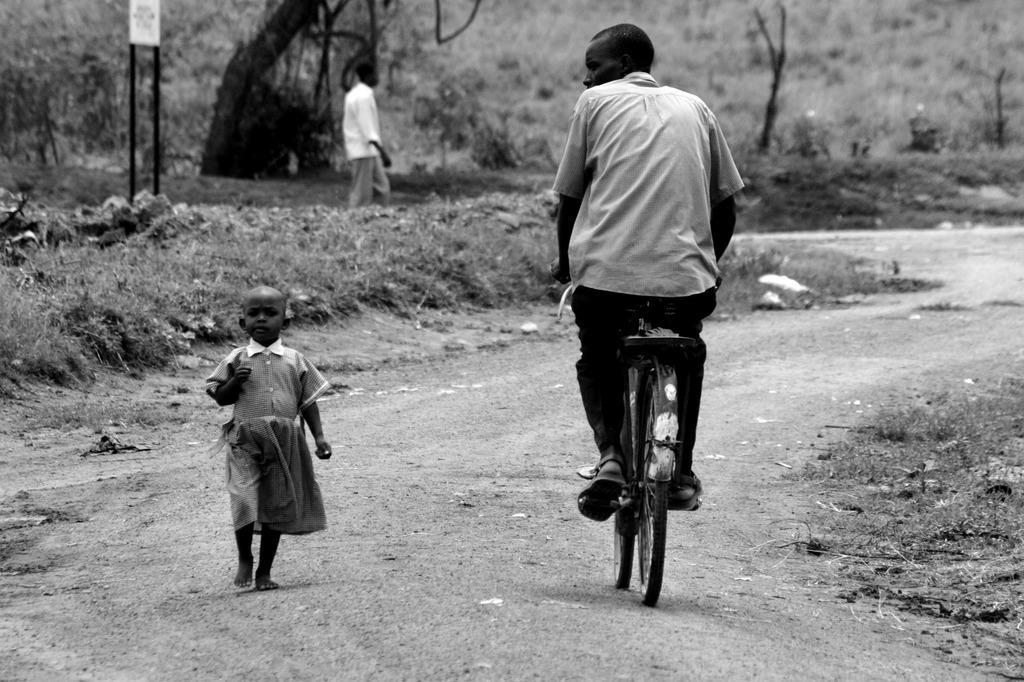Please provide a concise description of this image. This is a black and white picture. On the background of the picture we can see trees. This is a board. Here we can see one girl walking on the road. Here We can see one man riding a bicycle. He is a man over here walking on the road. 